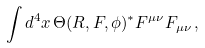<formula> <loc_0><loc_0><loc_500><loc_500>\int d ^ { 4 } x \, \Theta ( R , F , \phi ) ^ { * } F ^ { \mu \nu } F _ { \mu \nu } \, ,</formula> 